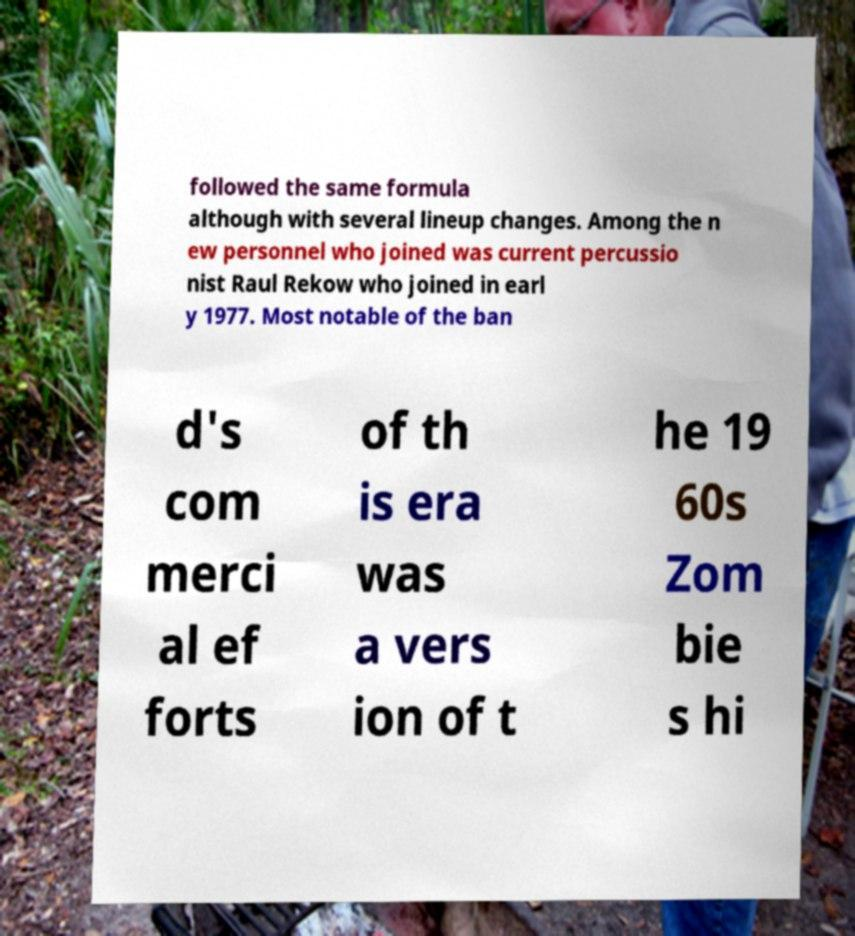Can you read and provide the text displayed in the image?This photo seems to have some interesting text. Can you extract and type it out for me? followed the same formula although with several lineup changes. Among the n ew personnel who joined was current percussio nist Raul Rekow who joined in earl y 1977. Most notable of the ban d's com merci al ef forts of th is era was a vers ion of t he 19 60s Zom bie s hi 